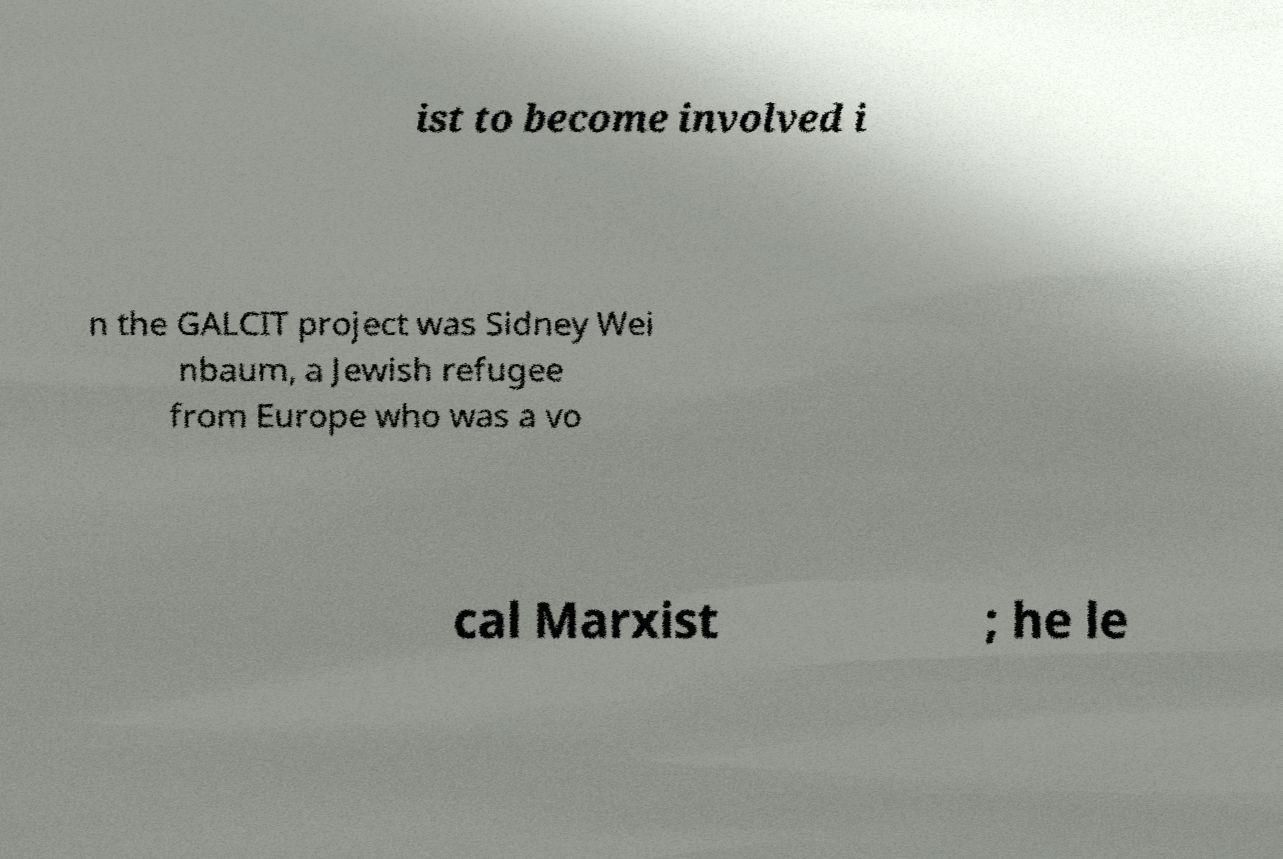What messages or text are displayed in this image? I need them in a readable, typed format. ist to become involved i n the GALCIT project was Sidney Wei nbaum, a Jewish refugee from Europe who was a vo cal Marxist ; he le 